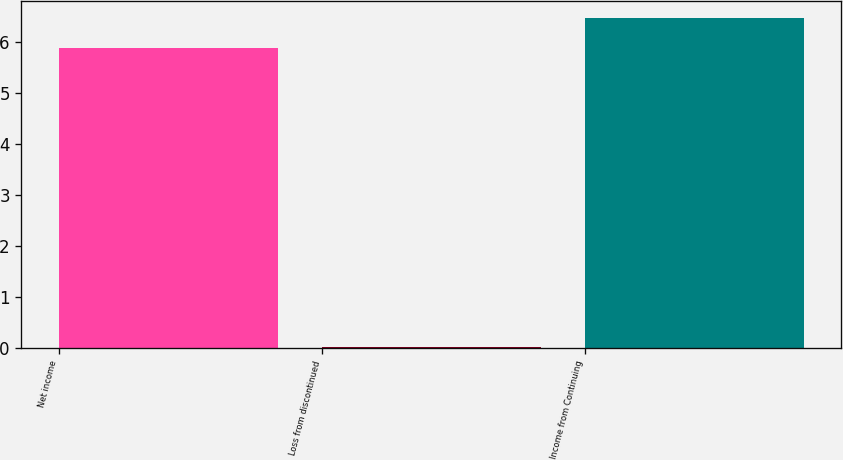Convert chart to OTSL. <chart><loc_0><loc_0><loc_500><loc_500><bar_chart><fcel>Net income<fcel>Loss from discontinued<fcel>Income from Continuing<nl><fcel>5.88<fcel>0.03<fcel>6.47<nl></chart> 